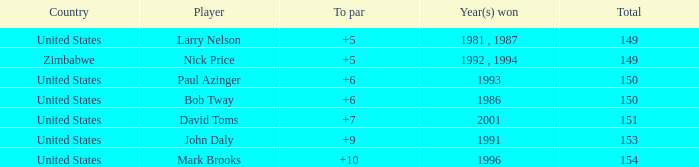What is the total for 1986 with a to par higher than 6? 0.0. 